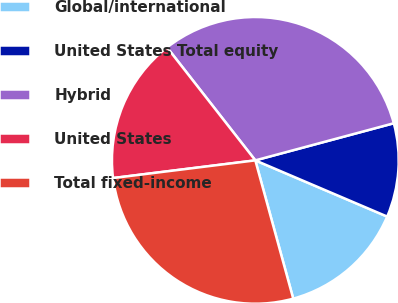Convert chart. <chart><loc_0><loc_0><loc_500><loc_500><pie_chart><fcel>Global/international<fcel>United States Total equity<fcel>Hybrid<fcel>United States<fcel>Total fixed-income<nl><fcel>14.33%<fcel>10.58%<fcel>31.39%<fcel>16.41%<fcel>27.29%<nl></chart> 